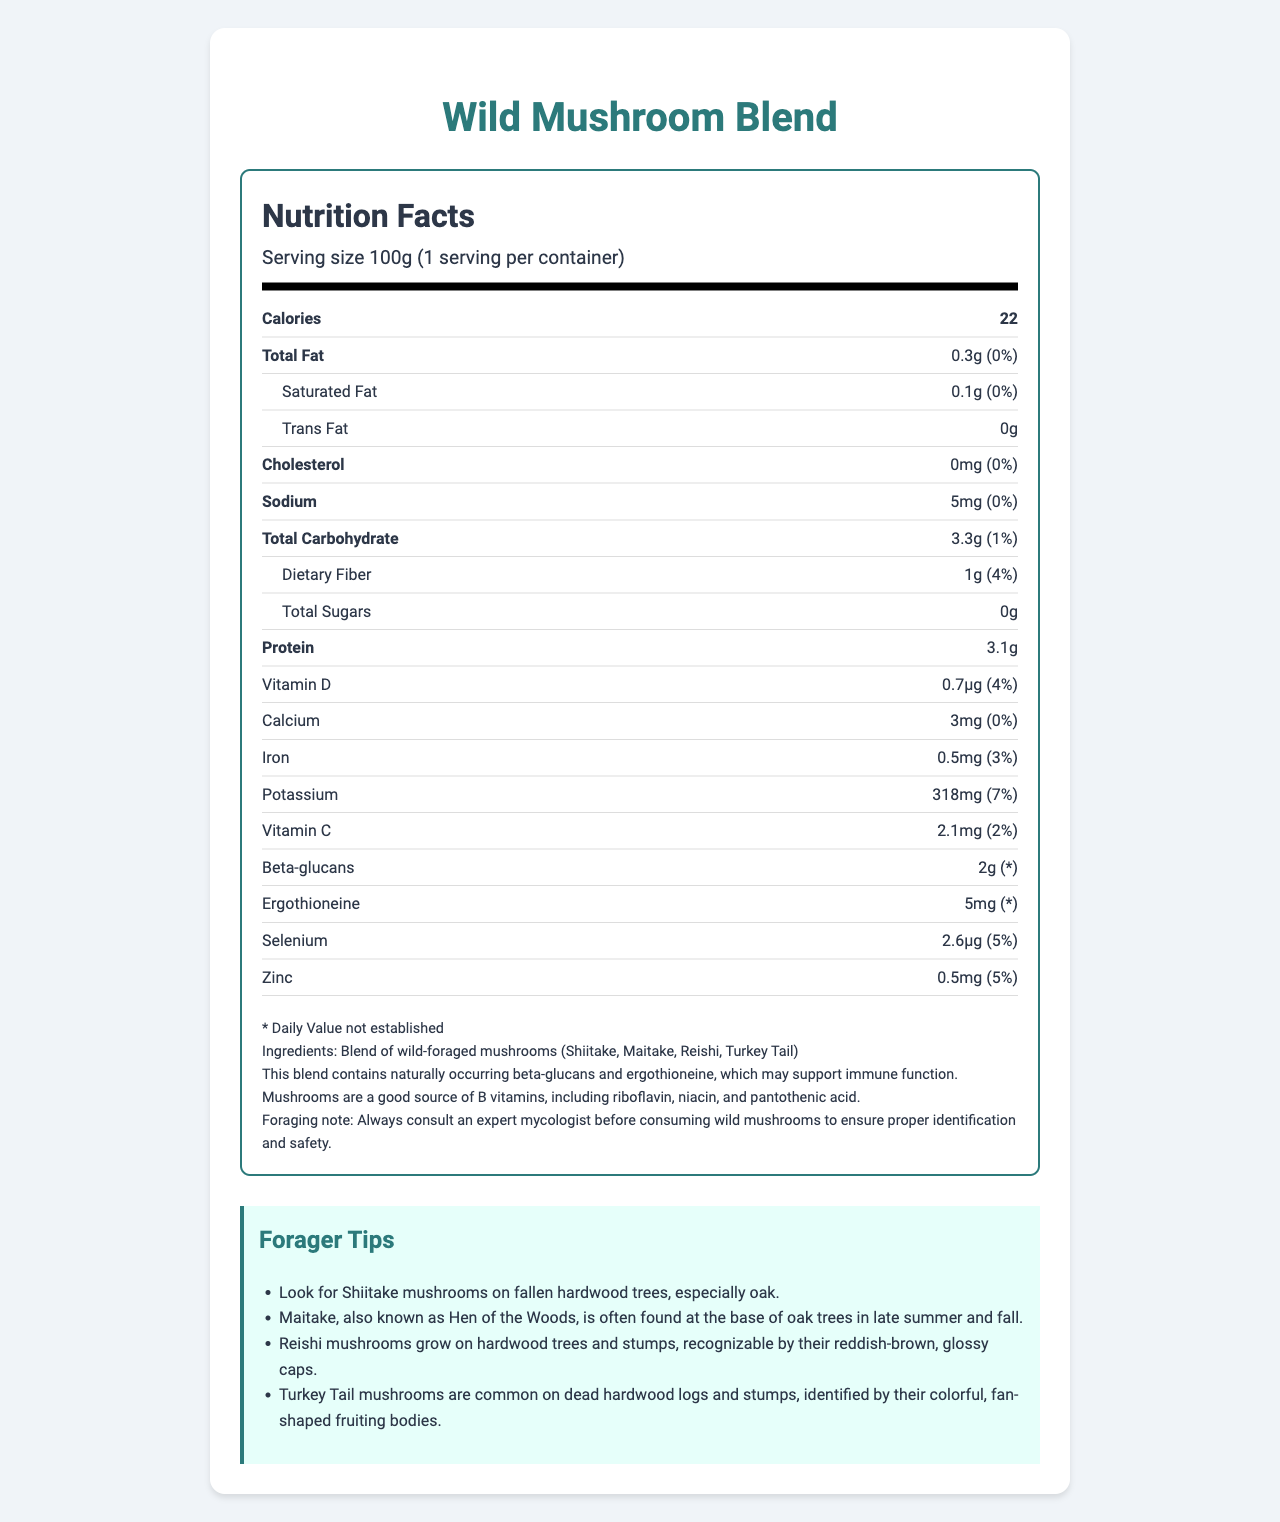what is the serving size for the Wild Mushroom Blend? The serving size is listed at the top of the nutrition facts as "Serving size 100g (1 serving per container)."
Answer: 100g how many calories are in one serving of the Wild Mushroom Blend? The calories are prominently displayed next to the "Calories" label in the nutrition facts section of the document.
Answer: 22 what percentage of the Daily Value for Dietary Fiber does the Wild Mushroom Blend provide? The Daily Value for Dietary Fiber is specified as "1g (4%)" in the nutrition facts.
Answer: 4% which type of fat does the Wild Mushroom Blend contain, and how much of it is present? The Wild Mushroom Blend contains 0.1g of saturated fat, as shown under the "Total Fat" section with an additional breakdown provided for saturated fat.
Answer: Saturated fat, 0.1g how much potassium does the Wild Mushroom Blend provide? The amount of potassium is indicated in the nutrition facts as "318mg (7%)".
Answer: 318mg does the Wild Mushroom Blend contain any Vitamin D? The presence of Vitamin D is confirmed in the nutrition facts, with a specified amount of 0.7μg.
Answer: Yes is ergothioneine content provided with a Daily Value percentage? The document states "Ergothioneine 5mg (* Daily Value not established)" indicating that the Daily Value percentage is not provided.
Answer: No which mushrooms are included in the Wild Mushroom Blend? A. Shiitake, Maitake, Reishi, Turkey Tail B. Cremini, Shiitake, Reishi, Oyster C. Morel, Porcini, Reishi, Lion's Mane The document lists the ingredients, which include Shiitake, Maitake, Reishi, and Turkey Tail.
Answer: A which nutrient has the highest percentage of Daily Value in the Wild Mushroom Blend? A. Potassium B. Zinc C. Vitamin D D. Selenium Potassium has the highest Daily Value percentage at 7%, compared to 5% for both Zinc and Selenium, and 4% for Vitamin D.
Answer: A does the Wild Mushroom Blend contain any trans fat? The amount of trans fat is listed as 0g in the nutrition facts, indicating that it does not contain any trans fat.
Answer: No which vitamins and minerals does the Wild Mushroom Blend specifically highlight in its additional information section for supporting immune function? The additional information mentions "This blend contains naturally occurring beta-glucans and ergothioneine, which may support immune function."
Answer: Beta-glucans and ergothioneine describe the main idea of the document. The document serves to inform the reader about the nutritional content and health benefits of the product, as well as safe foraging practices for the various mushroom types included in the blend.
Answer: The document is a Nutrition Facts Label for a Wild Mushroom Blend. It includes nutritional information on calories, fats, cholesterol, sodium, carbohydrates, sugars, protein, and various vitamins and minerals for a 100g serving. Additionally, it highlights the presence of immune-boosting compounds like beta-glucans and ergothioneine, provides ingredient details, and offers foraging tips for identifying and harvesting the included mushrooms. what time of year is best to forage for Maitake mushrooms? The forager tips specify that "Maitake, also known as Hen of the Woods, is often found at the base of oak trees in late summer and fall."
Answer: Late summer and fall can the document provide information on whether the mushrooms were ethically harvested? The document does not include any details regarding the ethical harvesting practices of the mushrooms.
Answer: Not enough information 